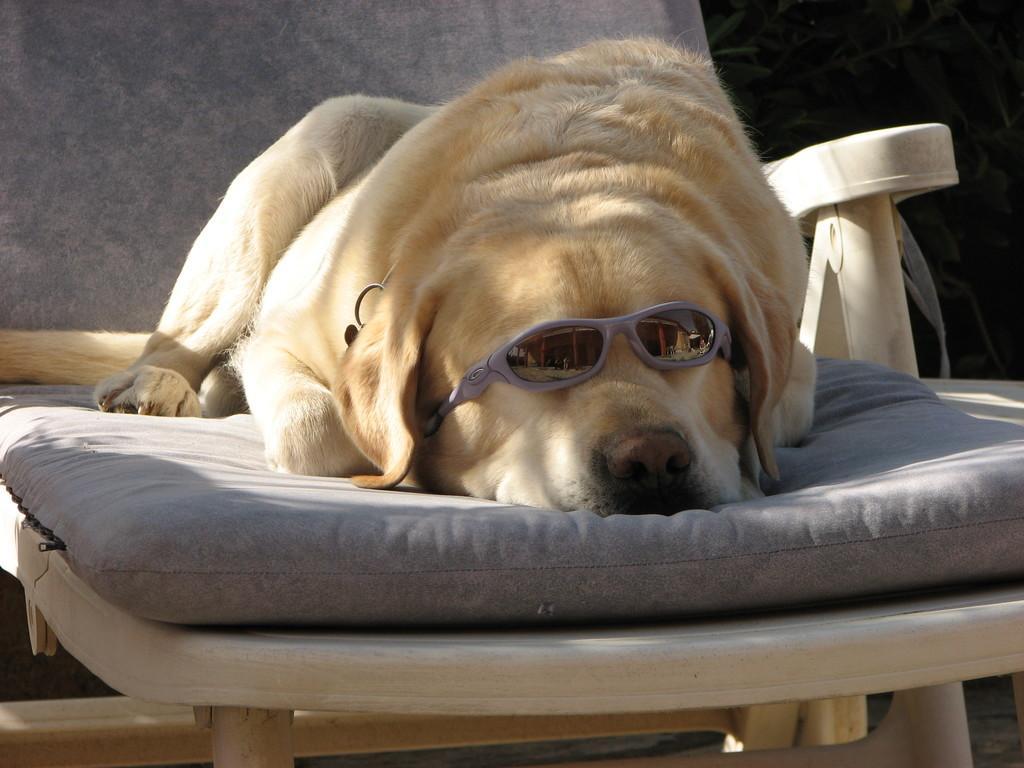In one or two sentences, can you explain what this image depicts? In this image there is a dog which is sleeping in the chair by wearing the spectacles. 